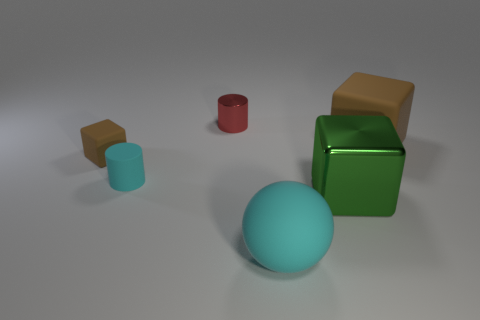Subtract all tiny brown matte cubes. How many cubes are left? 2 Add 2 small green metal balls. How many objects exist? 8 Subtract all brown cubes. How many cubes are left? 1 Subtract 1 spheres. How many spheres are left? 0 Add 1 tiny blue shiny things. How many tiny blue shiny things exist? 1 Subtract 0 gray blocks. How many objects are left? 6 Subtract all cylinders. How many objects are left? 4 Subtract all yellow blocks. Subtract all brown balls. How many blocks are left? 3 Subtract all blue spheres. How many green cylinders are left? 0 Subtract all matte things. Subtract all purple rubber cylinders. How many objects are left? 2 